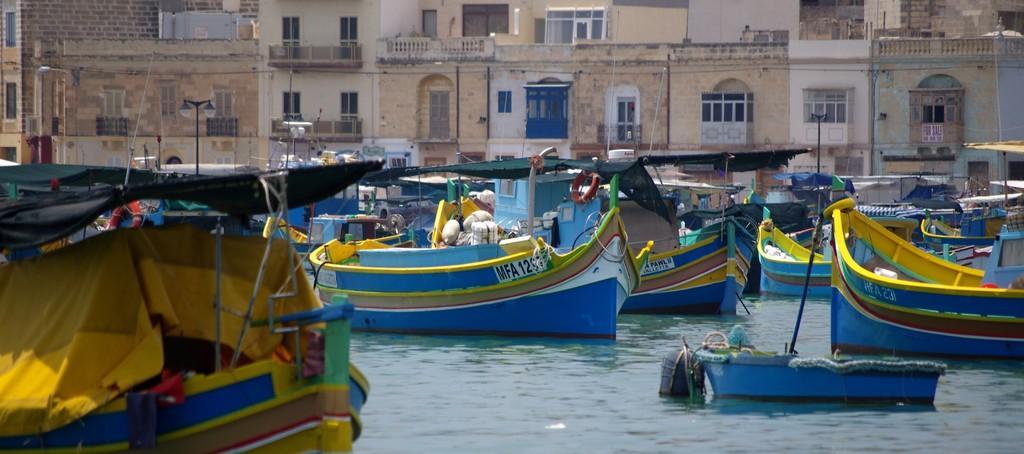Could you give a brief overview of what you see in this image? In this image there are many boats on the water. Behind the boats there are buildings. There are windows, doors and railings to the buildings. There are street light poles in front of the buildings. At the bottom there is the water. 